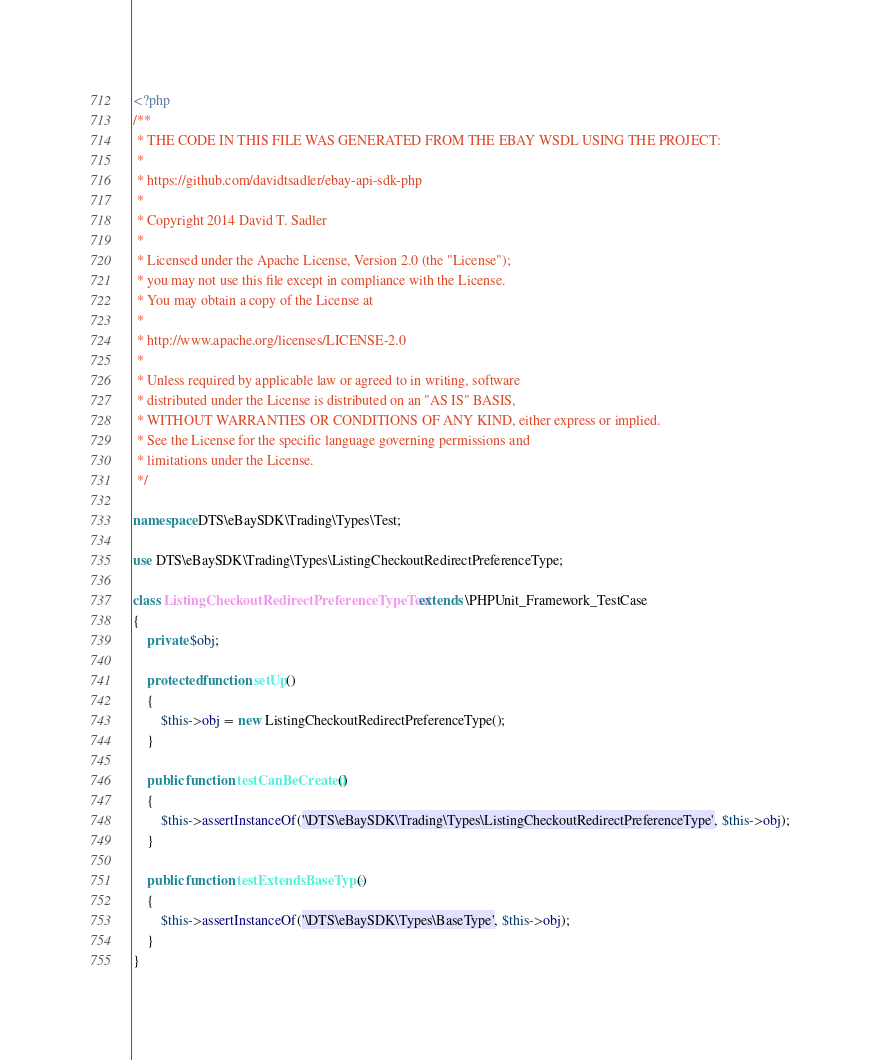Convert code to text. <code><loc_0><loc_0><loc_500><loc_500><_PHP_><?php
/**
 * THE CODE IN THIS FILE WAS GENERATED FROM THE EBAY WSDL USING THE PROJECT:
 *
 * https://github.com/davidtsadler/ebay-api-sdk-php
 *
 * Copyright 2014 David T. Sadler
 *
 * Licensed under the Apache License, Version 2.0 (the "License");
 * you may not use this file except in compliance with the License.
 * You may obtain a copy of the License at
 *
 * http://www.apache.org/licenses/LICENSE-2.0
 *
 * Unless required by applicable law or agreed to in writing, software
 * distributed under the License is distributed on an "AS IS" BASIS,
 * WITHOUT WARRANTIES OR CONDITIONS OF ANY KIND, either express or implied.
 * See the License for the specific language governing permissions and
 * limitations under the License.
 */

namespace DTS\eBaySDK\Trading\Types\Test;

use DTS\eBaySDK\Trading\Types\ListingCheckoutRedirectPreferenceType;

class ListingCheckoutRedirectPreferenceTypeTest extends \PHPUnit_Framework_TestCase
{
    private $obj;

    protected function setUp()
    {
        $this->obj = new ListingCheckoutRedirectPreferenceType();
    }

    public function testCanBeCreated()
    {
        $this->assertInstanceOf('\DTS\eBaySDK\Trading\Types\ListingCheckoutRedirectPreferenceType', $this->obj);
    }

    public function testExtendsBaseType()
    {
        $this->assertInstanceOf('\DTS\eBaySDK\Types\BaseType', $this->obj);
    }
}
</code> 